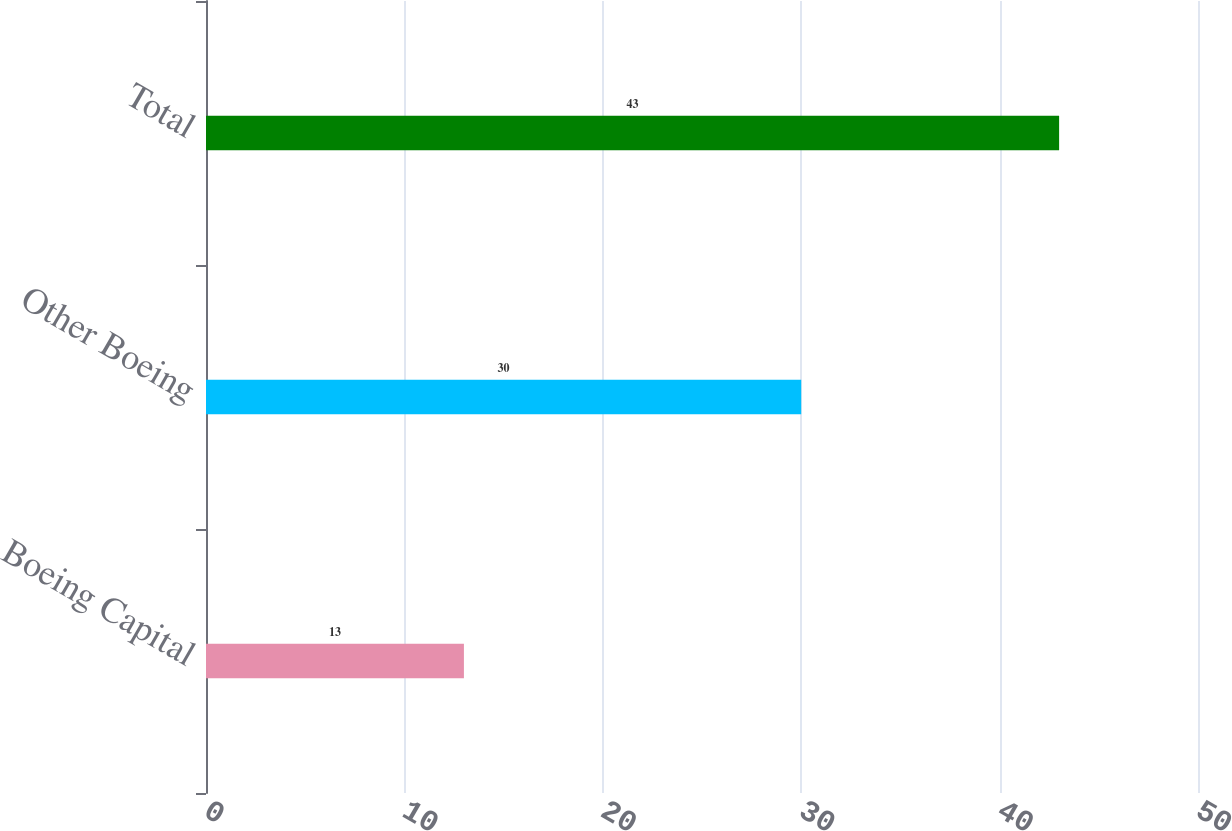Convert chart. <chart><loc_0><loc_0><loc_500><loc_500><bar_chart><fcel>Boeing Capital<fcel>Other Boeing<fcel>Total<nl><fcel>13<fcel>30<fcel>43<nl></chart> 